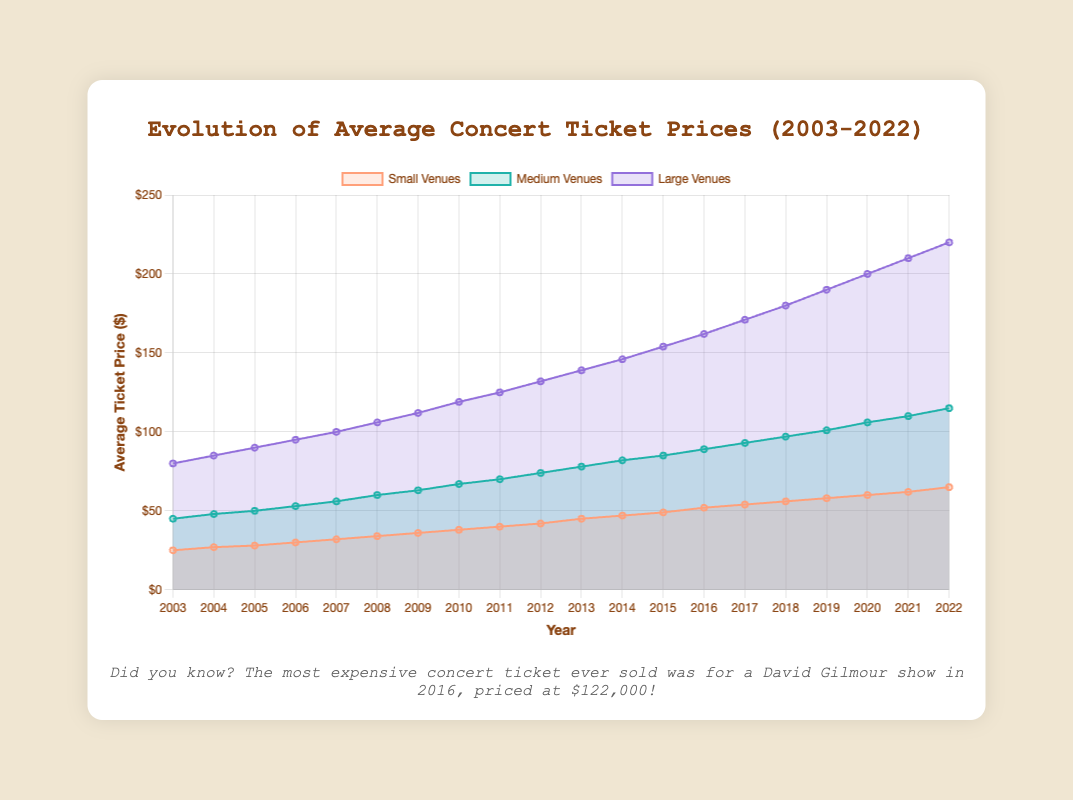What is the trend of average ticket prices for large venues over the years? The chart shows a consistent increase in ticket prices for large venues from 2003 to 2022. Starting at $80 in 2003 and reaching $220 in 2022, the trend demonstrates yearly growth without any decreases.
Answer: Consistent increase Which venue size experienced the highest increase in average ticket prices from 2003 to 2022? From the chart, we see that large venues had ticket prices rise from $80 to $220, which is an increase of $140. Medium venues increased from $45 to $115, a $70 increase. Small venues increased from $25 to $65, a $40 increase. Therefore, large venues experienced the highest increase.
Answer: Large venues How do the ticket prices for small venues in 2022 compare with those for medium venues in 2010? The chart indicates that the ticket price for small venues in 2022 is $65, while the ticket price for medium venues in 2010 is $67. This shows that the prices are quite similar, with medium venues in 2010 being slightly higher by $2.
Answer: Medium venues in 2010 are higher by $2 How much did the average ticket price for medium venues increase between 2007 and 2015? According to the chart, the average ticket price for medium venues was $56 in 2007 and increased to $85 by 2015. The difference between these values is $85 - $56, which equals $29.
Answer: $29 Which year did the average ticket price for small venues first reach $50? Observing the chart, the average ticket price for small venues reached $50 between 2011 ($49) and 2013 ($52). Therefore, the closest year it first reached $50 would be 2013.
Answer: 2013 Between 2005 and 2015, which venue size experienced the highest rate of increase in average ticket prices? To find the rate of increase, we consider the starting and ending prices for each venue size from 2005 to 2015. Small venues: $28 to $49 (increase of $21); Medium venues: $50 to $85 (increase of $35); Large venues: $90 to $154 (increase of $64). Dividing each increase by the number of years (10), large venues have the highest annual rate of increase ($64/10 = $6.4/year), followed by medium ($35/10 = $3.5/year) and small venues ($21/10 = $2.1/year).
Answer: Large venues What was the highest average ticket price for small venues over the last 20 years? Based on the chart, the highest average ticket price for small venues over the last 20 years was in 2022 at $65.
Answer: $65 Compare 2015 ticket prices for small and large venues. Which had a greater difference from the 2010 prices? In 2010, small venue ticket prices were $38 and large venue ticket prices were $119. In 2015, small venue ticket prices were $49 and large venue ticket prices were $154. The increase for small venues was $49 - $38 = $11, and the increase for large venues was $154 - $119 = $35. Therefore, large venues had a greater difference from the 2010 prices.
Answer: Large venues By how much did the ticket prices for medium venues surpass small venues in 2022? In 2022, the chart shows that the average ticket price for medium venues was $115 while for small venues it was $65. The difference between these prices is $115 - $65, which is $50.
Answer: $50 